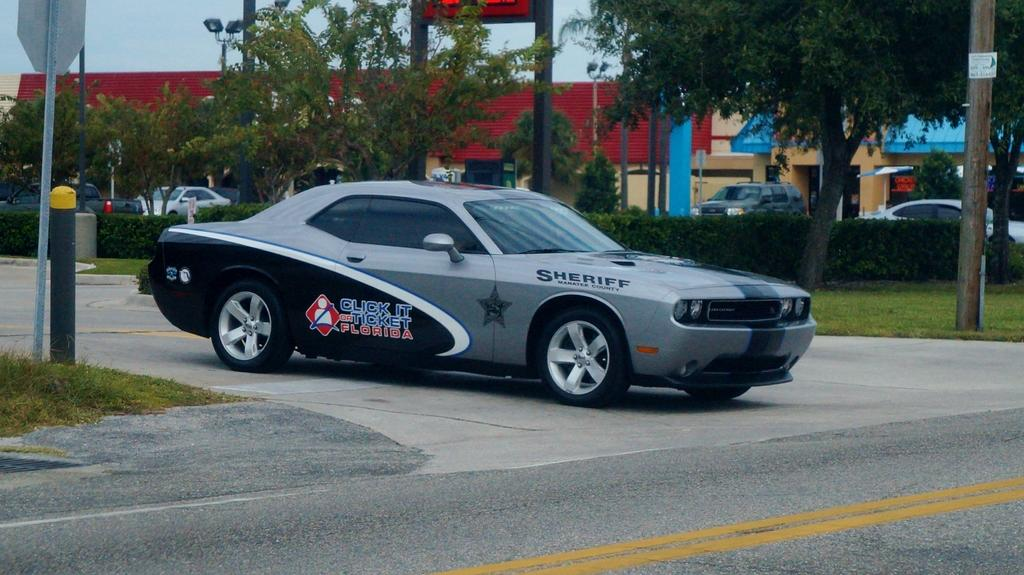What is the main subject of the image? The main subject of the image is a car. Where is the car located in the image? The car is on the road in the image. What colors can be seen on the car? The car is grey and black in color. What can be seen on the left side of the image? There are two poles on the left side of the image. What is visible in the background of the image? There are trees and houses in the background of the image. How many doors can be seen on the car in the image? There is no information about the number of doors on the car in the image. Are there any horses visible in the image? There are no horses present in the image. 